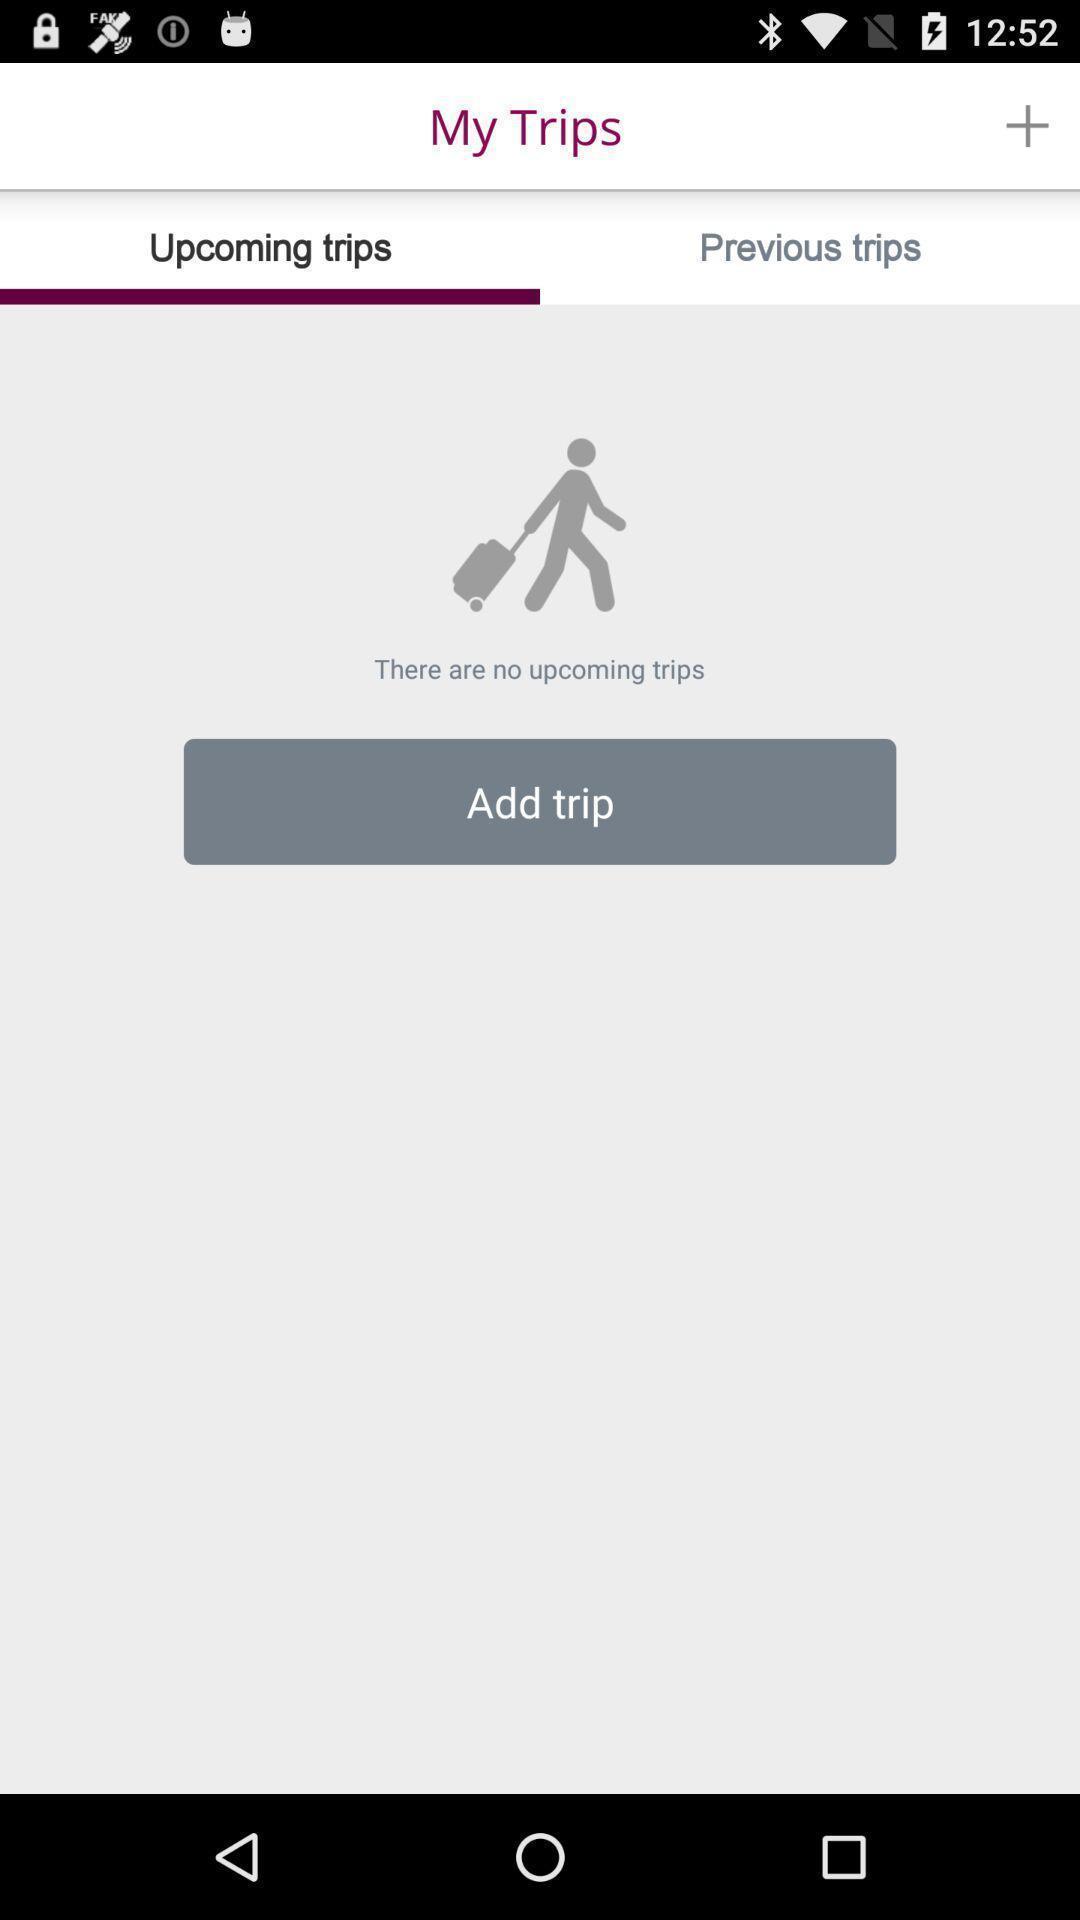Please provide a description for this image. Screen displaying upcoming trips page. 